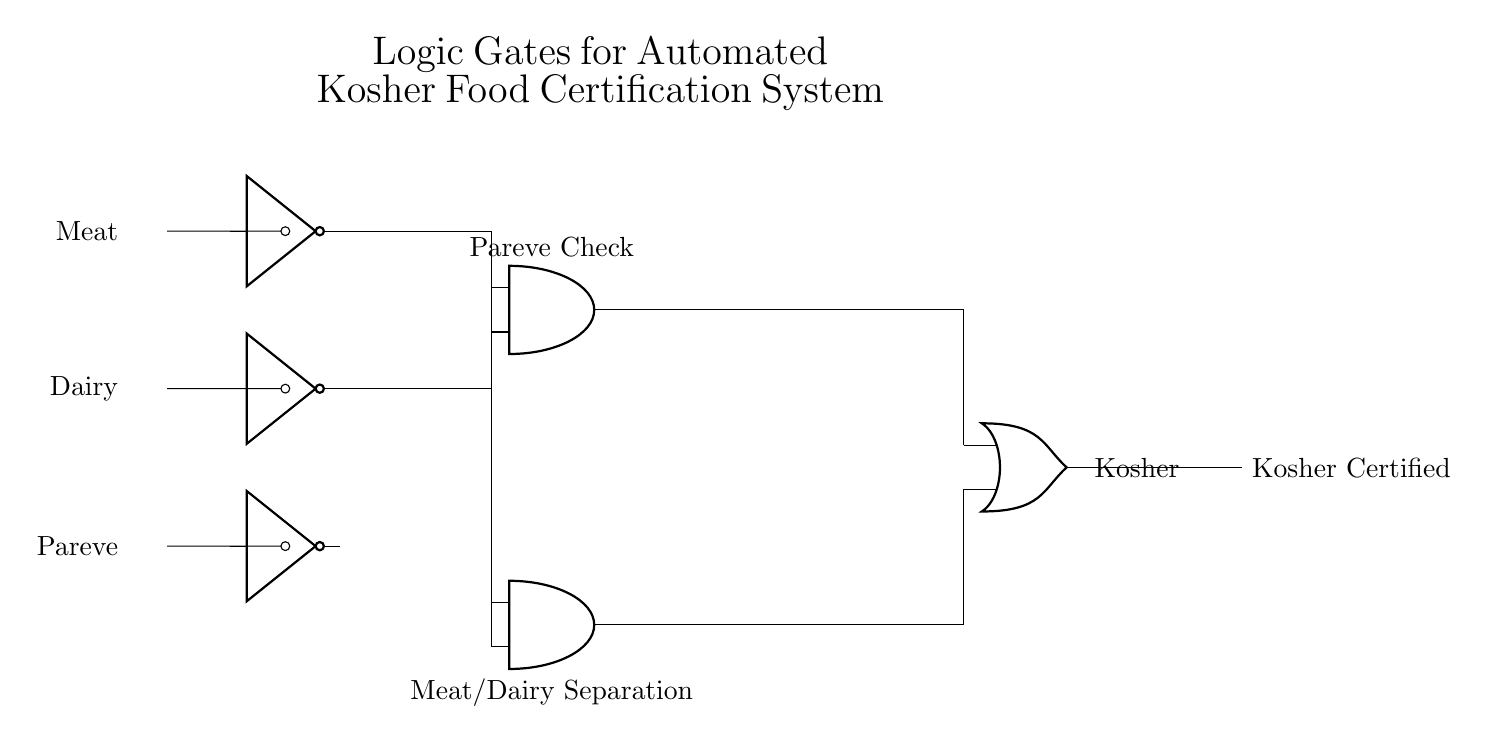What do the inputs represent in this circuit? The inputs represent meat, dairy, and pareve food types, which are essential for determining kosher certification.
Answer: Meat, dairy, pareve Which logic gates are used in the circuit? The circuit uses NOT gates, AND gates, and an OR gate to process the input signals and determine kosher certification.
Answer: NOT, AND, OR What does the output indicate? The output indicates whether the food item is kosher certified based on the logical conditions applied in the circuit.
Answer: Kosher Certified How many AND gates are in the circuit? There are two AND gates in the circuit, each performing a different logical operation based on the inputs.
Answer: Two What is the purpose of the first AND gate? The first AND gate checks for the combination of NOT meat and NOT dairy to ensure that there is no mixing of meat and dairy, which is a key principle in kosher guidelines.
Answer: Pareve Check What condition will result in the output being kosher certified? The output will be kosher certified when either the food is pareve (not meat and not dairy) or it confirms that meat and dairy are not combined.
Answer: Either condition met What does the second AND gate verify? The second AND gate verifies the separation between meat and dairy by checking that both inputs are NOT meat and NOT dairy, reinforcing kosher standards.
Answer: Meat/Dairy Separation 